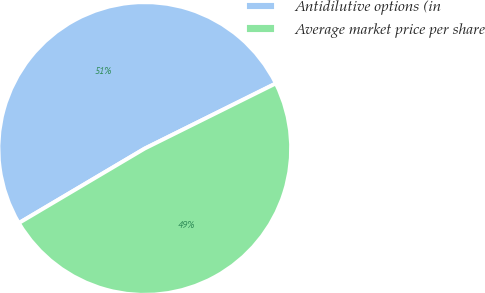<chart> <loc_0><loc_0><loc_500><loc_500><pie_chart><fcel>Antidilutive options (in<fcel>Average market price per share<nl><fcel>51.17%<fcel>48.83%<nl></chart> 